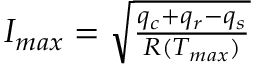<formula> <loc_0><loc_0><loc_500><loc_500>\begin{array} { r } { I _ { \max } = \sqrt { \frac { q _ { c } + q _ { r } - q _ { s } } { R ( T _ { \max } ) } } } \end{array}</formula> 